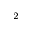Convert formula to latex. <formula><loc_0><loc_0><loc_500><loc_500>^ { 2 }</formula> 